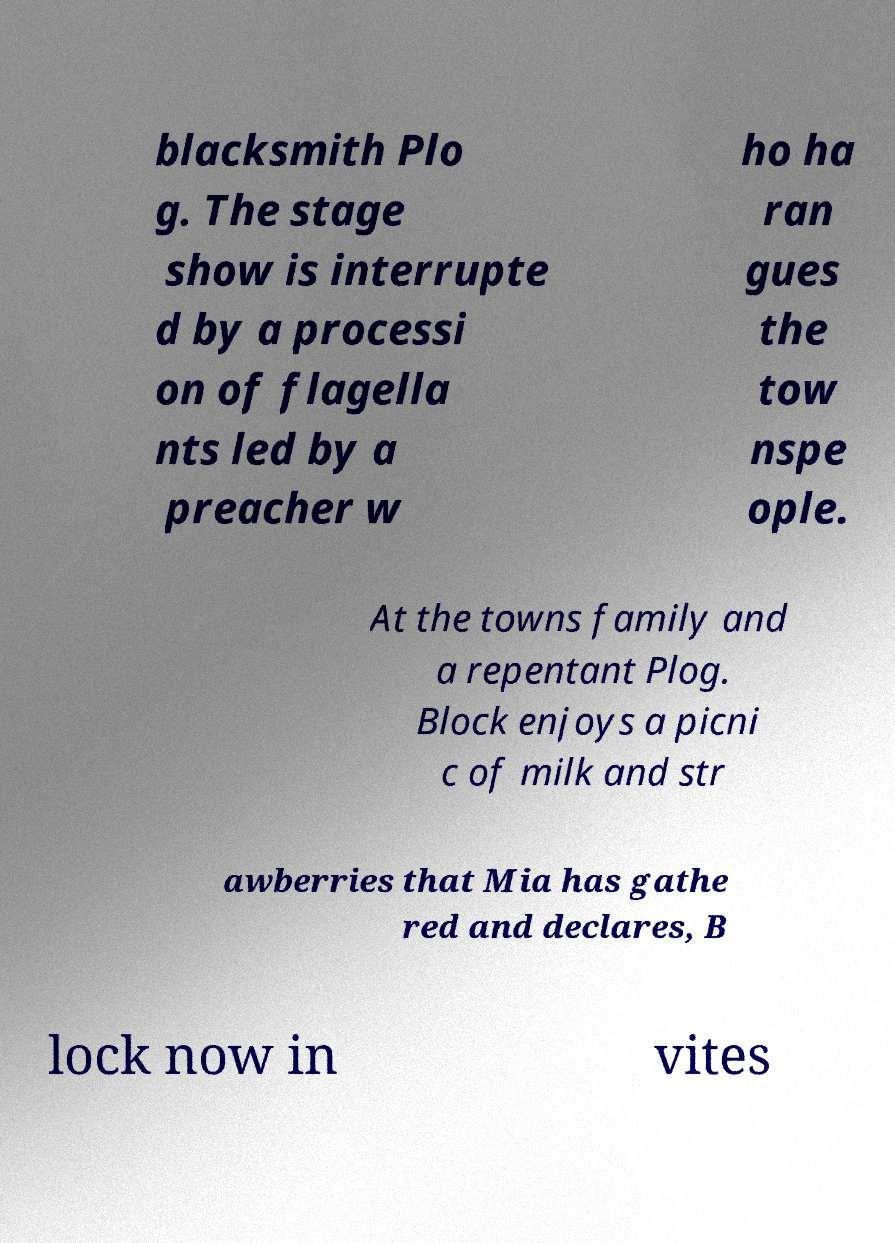Can you read and provide the text displayed in the image?This photo seems to have some interesting text. Can you extract and type it out for me? blacksmith Plo g. The stage show is interrupte d by a processi on of flagella nts led by a preacher w ho ha ran gues the tow nspe ople. At the towns family and a repentant Plog. Block enjoys a picni c of milk and str awberries that Mia has gathe red and declares, B lock now in vites 